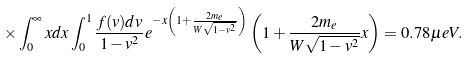Convert formula to latex. <formula><loc_0><loc_0><loc_500><loc_500>\times \int _ { 0 } ^ { \infty } x d x \int _ { 0 } ^ { 1 } \frac { f ( v ) d v } { 1 - v ^ { 2 } } e ^ { - x \left ( 1 + \frac { 2 m _ { e } } { W \sqrt { 1 - v ^ { 2 } } } \right ) } \left ( 1 + \frac { 2 m _ { e } } { W \sqrt { 1 - v ^ { 2 } } } x \right ) = 0 . 7 8 \mu e V .</formula> 